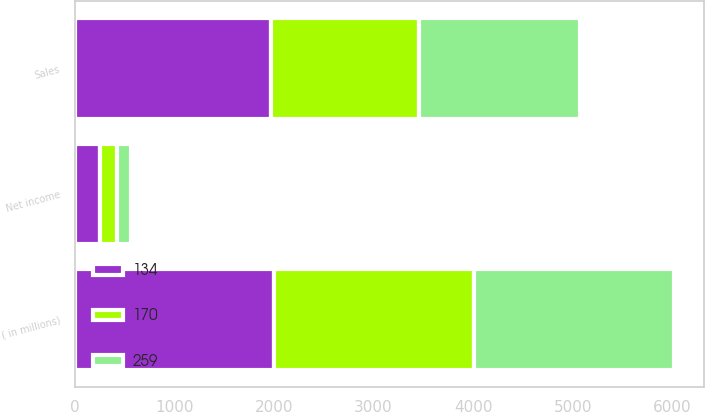Convert chart to OTSL. <chart><loc_0><loc_0><loc_500><loc_500><stacked_bar_chart><ecel><fcel>( in millions)<fcel>Sales<fcel>Net income<nl><fcel>259<fcel>2007<fcel>1622<fcel>134<nl><fcel>170<fcel>2006<fcel>1479<fcel>170<nl><fcel>134<fcel>2005<fcel>1975<fcel>259<nl></chart> 